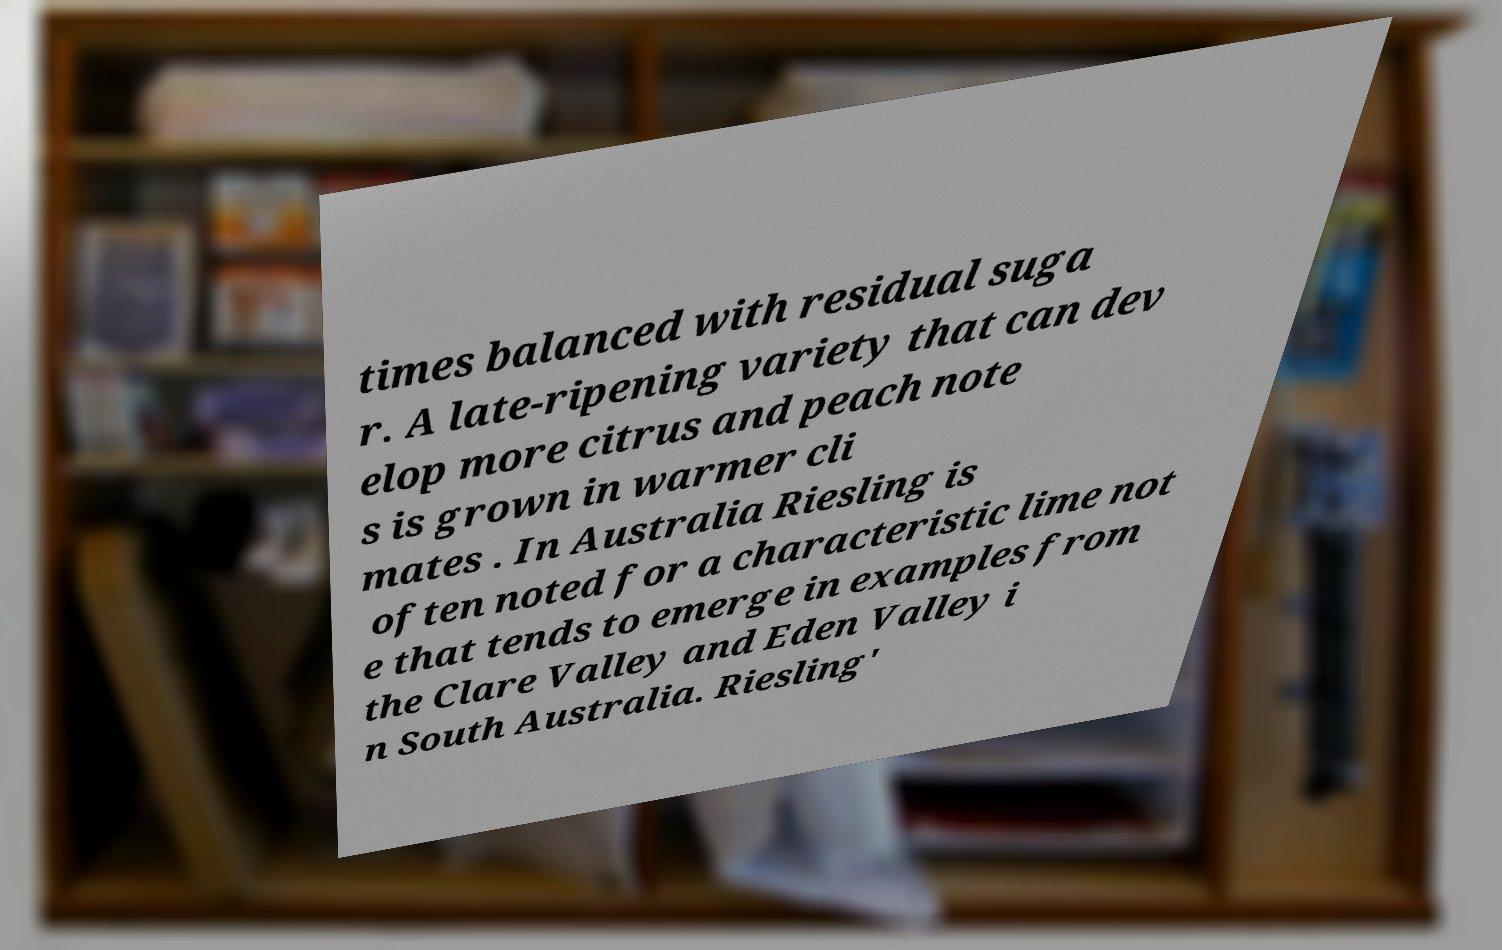For documentation purposes, I need the text within this image transcribed. Could you provide that? times balanced with residual suga r. A late-ripening variety that can dev elop more citrus and peach note s is grown in warmer cli mates . In Australia Riesling is often noted for a characteristic lime not e that tends to emerge in examples from the Clare Valley and Eden Valley i n South Australia. Riesling' 